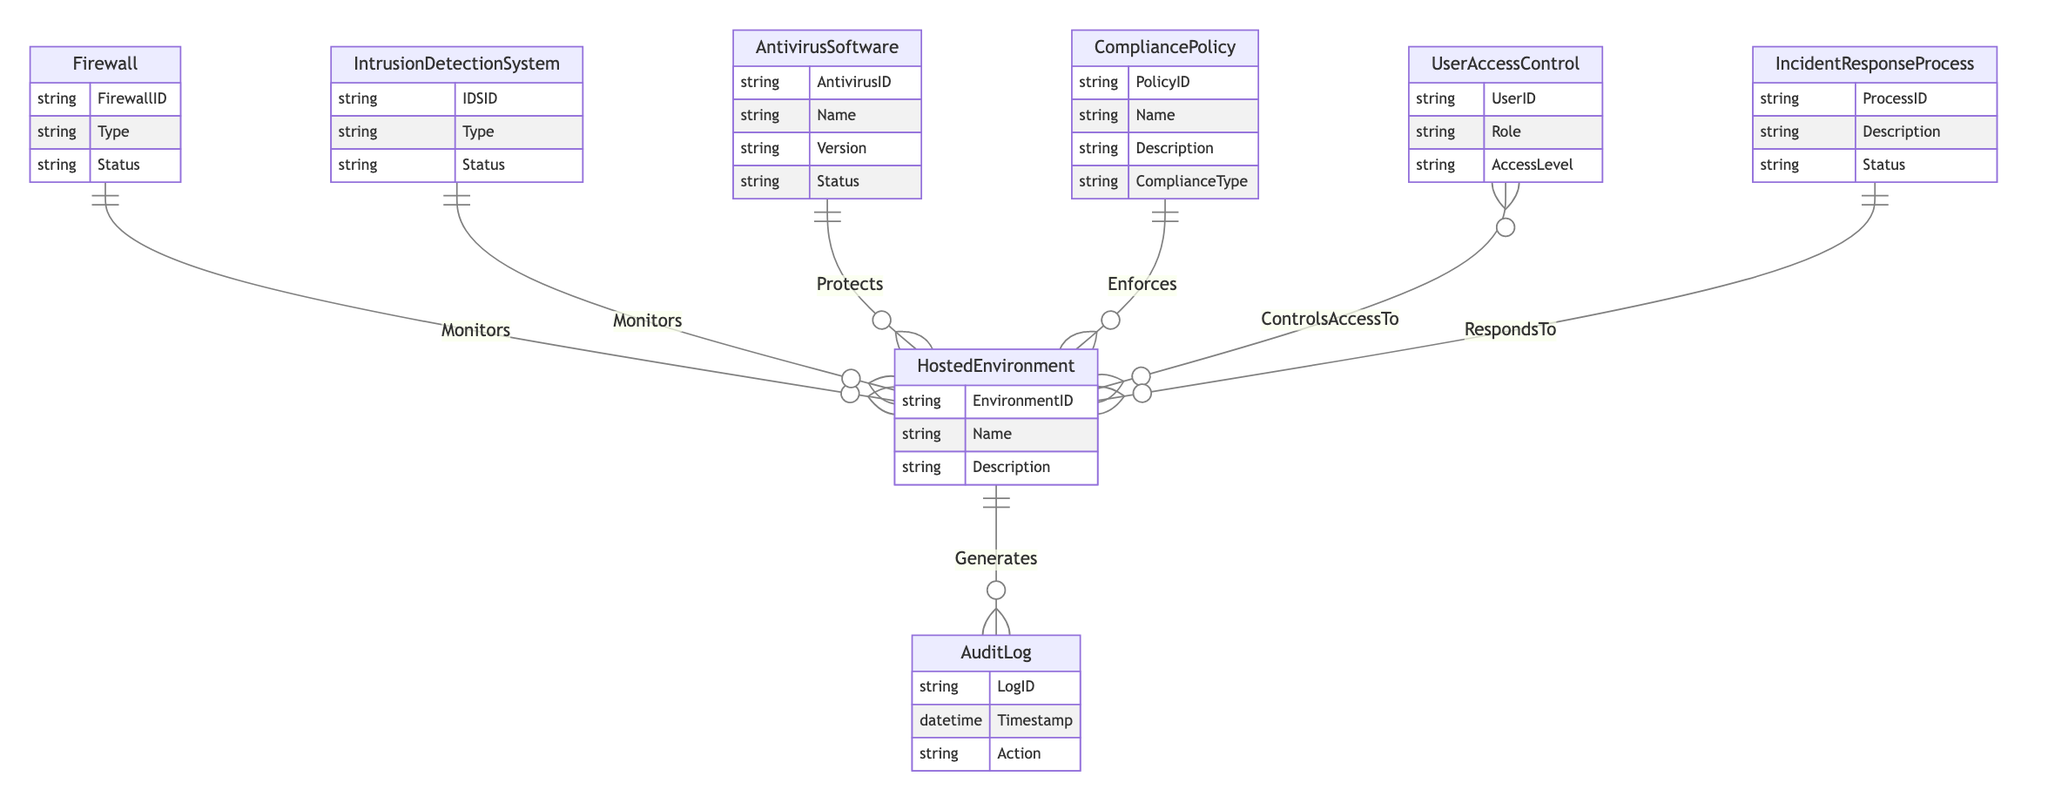What entities are monitored by the Firewall? The Firewall entity monitors the HostedEnvironment as shown by the "Monitors" relationship connecting them.
Answer: HostedEnvironment How many entities have a status attribute? By inspecting the entities in the diagram, the Firewall, IntrusionDetectionSystem, AntivirusSoftware, and IncidentResponseProcess all have a "Status" attribute, making a total of four entities.
Answer: Four What type of relationship exists between CompliancePolicy and HostedEnvironment? The relationship named "Enforces" exists between CompliancePolicy and HostedEnvironment, indicating that CompliancePolicy enforces controls within the HostedEnvironment.
Answer: One-to-Many How many AuditLog records can be generated by a single HostedEnvironment? According to the relationship "Generates," one HostedEnvironment can generate many AuditLog records, suggesting that there is no limit, but it is represented as one-to-many.
Answer: Many What are the access control relationships related to UserAccessControl? The UserAccessControl entity has a many-to-many relationship with HostedEnvironment, indicating that multiple user access controls can manage access to multiple hosted environments.
Answer: Many-to-Many What is the main purpose of the IncidentResponseProcess in relation to HostedEnvironment? The IncidentResponseProcess responds to incidents within the HostedEnvironment, as per the "RespondsTo" relationship linking them.
Answer: Responds Can a single AntivirusSoftware protect multiple HostedEnvironments? Yes, the relationship "Protects" indicates that a single AntivirusSoftware can protect multiple HostedEnvironments, making it a one-to-many relationship.
Answer: Yes How are audit logs generated in the system? AuditLogs are generated from HostedEnvironment, meaning that each hosted environment generates multiple audit log entries as indicated by the "Generates" relationship.
Answer: Generates What describes the role of UserAccessControl? UserAccessControl controls access to HostedEnvironment, as illustrated by the many-to-many relationship, meaning that it has a significant role in user permissions and access levels across hosted environments.
Answer: Controls Access To 